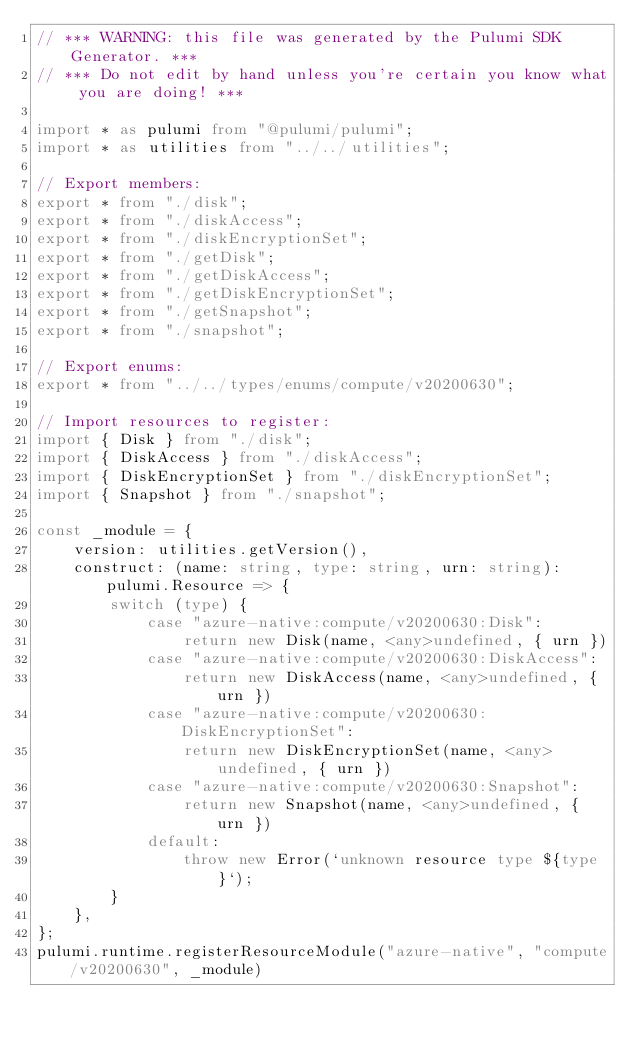<code> <loc_0><loc_0><loc_500><loc_500><_TypeScript_>// *** WARNING: this file was generated by the Pulumi SDK Generator. ***
// *** Do not edit by hand unless you're certain you know what you are doing! ***

import * as pulumi from "@pulumi/pulumi";
import * as utilities from "../../utilities";

// Export members:
export * from "./disk";
export * from "./diskAccess";
export * from "./diskEncryptionSet";
export * from "./getDisk";
export * from "./getDiskAccess";
export * from "./getDiskEncryptionSet";
export * from "./getSnapshot";
export * from "./snapshot";

// Export enums:
export * from "../../types/enums/compute/v20200630";

// Import resources to register:
import { Disk } from "./disk";
import { DiskAccess } from "./diskAccess";
import { DiskEncryptionSet } from "./diskEncryptionSet";
import { Snapshot } from "./snapshot";

const _module = {
    version: utilities.getVersion(),
    construct: (name: string, type: string, urn: string): pulumi.Resource => {
        switch (type) {
            case "azure-native:compute/v20200630:Disk":
                return new Disk(name, <any>undefined, { urn })
            case "azure-native:compute/v20200630:DiskAccess":
                return new DiskAccess(name, <any>undefined, { urn })
            case "azure-native:compute/v20200630:DiskEncryptionSet":
                return new DiskEncryptionSet(name, <any>undefined, { urn })
            case "azure-native:compute/v20200630:Snapshot":
                return new Snapshot(name, <any>undefined, { urn })
            default:
                throw new Error(`unknown resource type ${type}`);
        }
    },
};
pulumi.runtime.registerResourceModule("azure-native", "compute/v20200630", _module)
</code> 